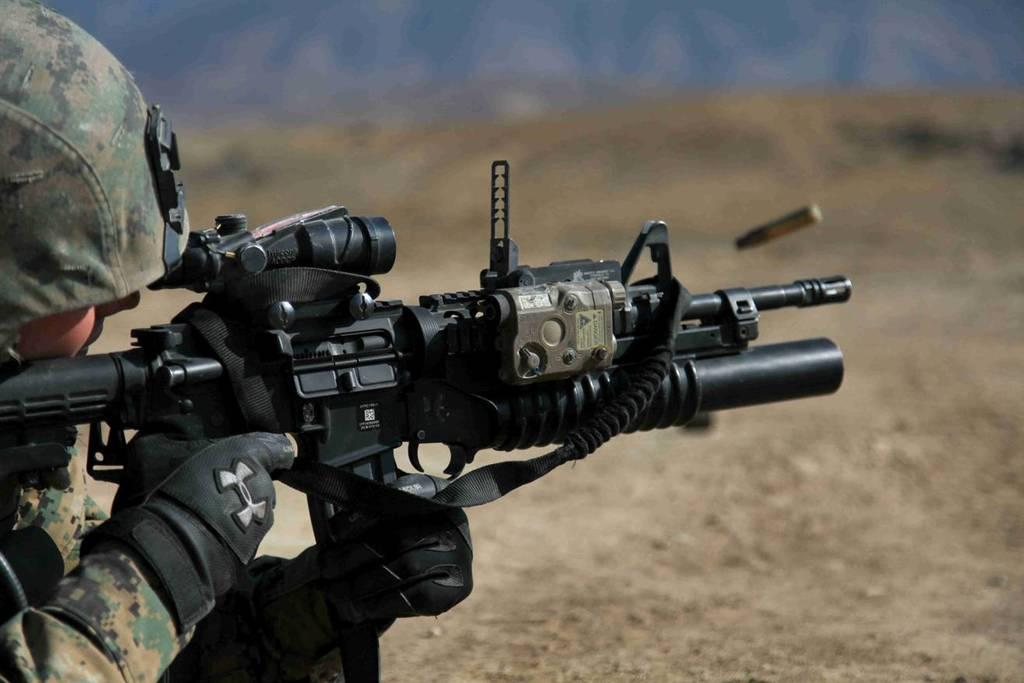What is the main activity of the people in the image? The people in the image are sitting around a table and having a meal. How many people are present in the image? The number of people is not specified, but there is a group of people present. What is on the table in the image? The table is not described in detail, but it is likely that there are plates, utensils, and possibly food and drinks. How many hours does it take for the grain to grow in the image? There is no grain present in the image, and therefore no growth can be observed. 